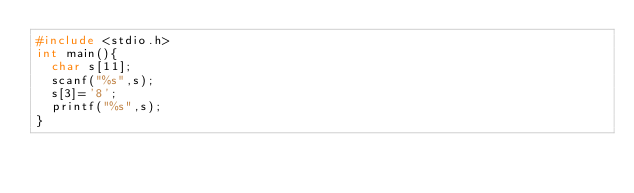<code> <loc_0><loc_0><loc_500><loc_500><_C_>#include <stdio.h>
int main(){
  char s[11];
  scanf("%s",s);
  s[3]='8';
  printf("%s",s);
}</code> 